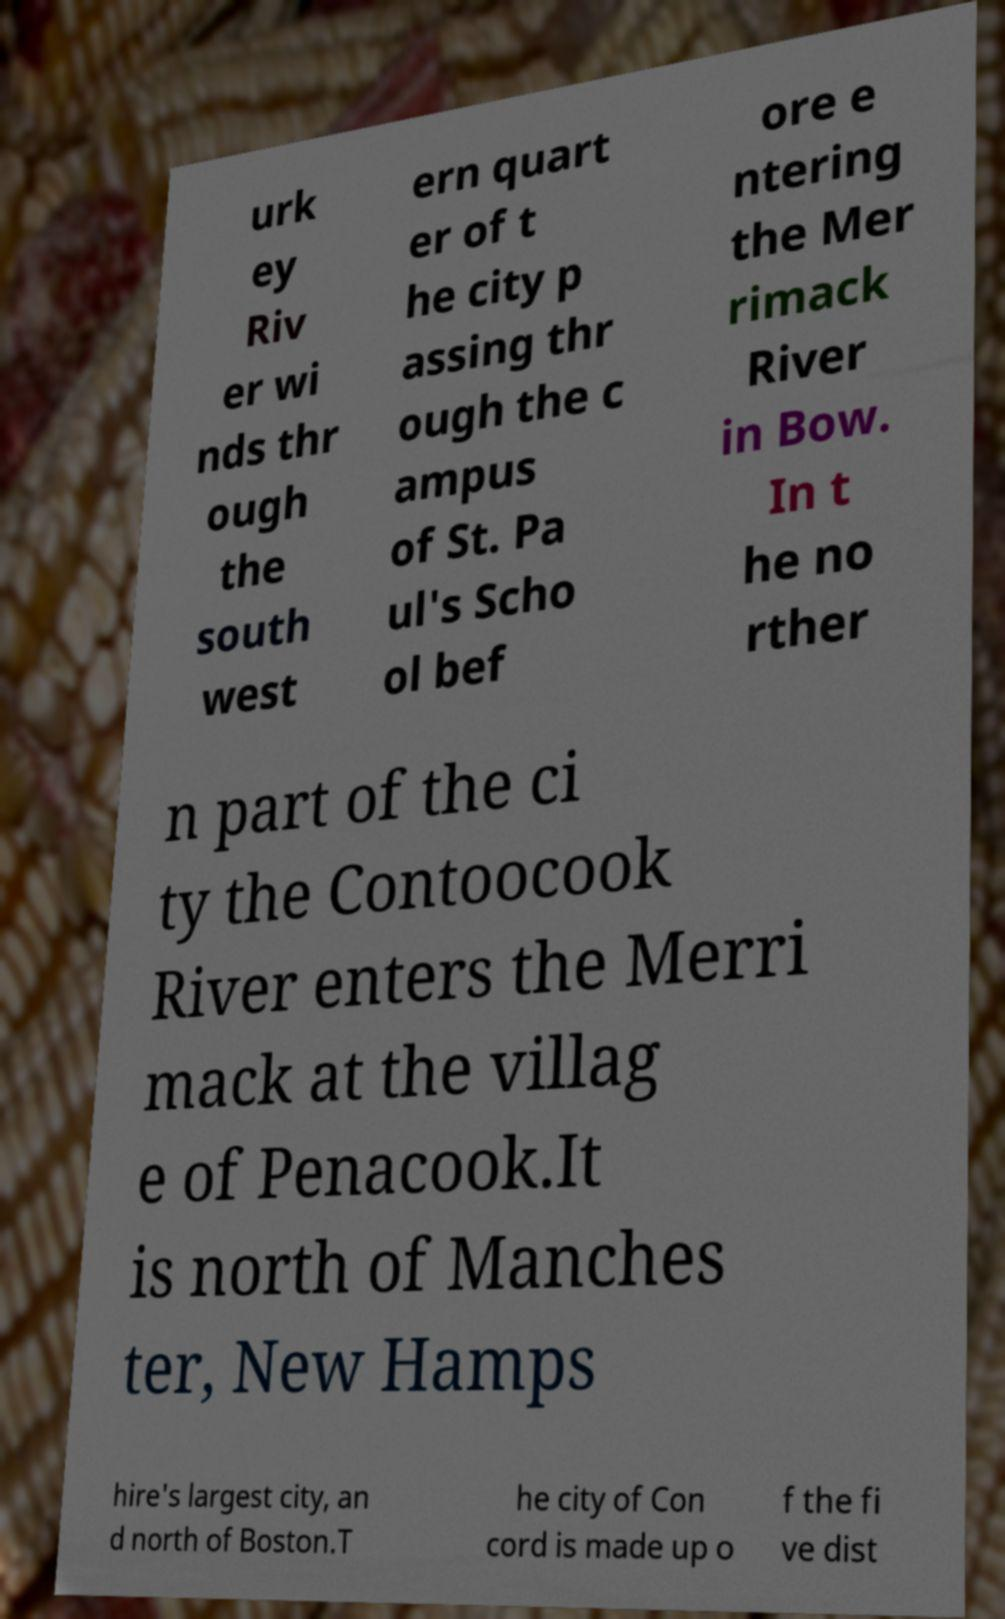Can you read and provide the text displayed in the image?This photo seems to have some interesting text. Can you extract and type it out for me? urk ey Riv er wi nds thr ough the south west ern quart er of t he city p assing thr ough the c ampus of St. Pa ul's Scho ol bef ore e ntering the Mer rimack River in Bow. In t he no rther n part of the ci ty the Contoocook River enters the Merri mack at the villag e of Penacook.It is north of Manches ter, New Hamps hire's largest city, an d north of Boston.T he city of Con cord is made up o f the fi ve dist 